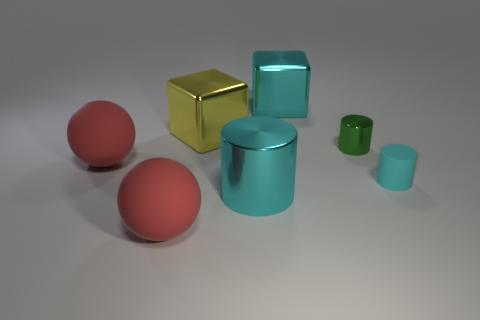Subtract all red blocks. How many cyan cylinders are left? 2 Subtract all small cylinders. How many cylinders are left? 1 Add 2 small yellow metallic objects. How many objects exist? 9 Subtract all cubes. How many objects are left? 5 Subtract all gray cylinders. Subtract all purple spheres. How many cylinders are left? 3 Subtract all big objects. Subtract all big cyan cylinders. How many objects are left? 1 Add 5 big cyan cylinders. How many big cyan cylinders are left? 6 Add 1 tiny matte objects. How many tiny matte objects exist? 2 Subtract 0 red blocks. How many objects are left? 7 